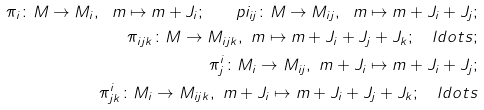Convert formula to latex. <formula><loc_0><loc_0><loc_500><loc_500>\pi _ { i } \colon M \rightarrow M _ { i } , \ m \mapsto m + J _ { i } ; \quad p i _ { i j } \colon M \rightarrow M _ { i j } , \ m \mapsto m + J _ { i } + J _ { j } ; \\ \pi _ { i j k } \colon M \rightarrow M _ { i j k } , \ m \mapsto m + J _ { i } + J _ { j } + J _ { k } ; \quad l d o t s ; \\ \pi ^ { i } _ { j } \colon M _ { i } \rightarrow M _ { i j } , \ m + J _ { i } \mapsto m + J _ { i } + J _ { j } ; \\ \pi ^ { i } _ { j k } \colon M _ { i } \rightarrow M _ { i j k } , \ m + J _ { i } \mapsto m + J _ { i } + J _ { j } + J _ { k } ; \quad l d o t s</formula> 